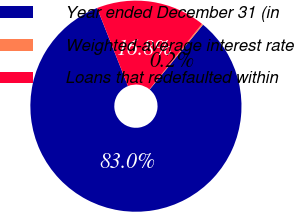<chart> <loc_0><loc_0><loc_500><loc_500><pie_chart><fcel>Year ended December 31 (in<fcel>Weighted-average interest rate<fcel>Loans that redefaulted within<nl><fcel>83.04%<fcel>0.2%<fcel>16.76%<nl></chart> 